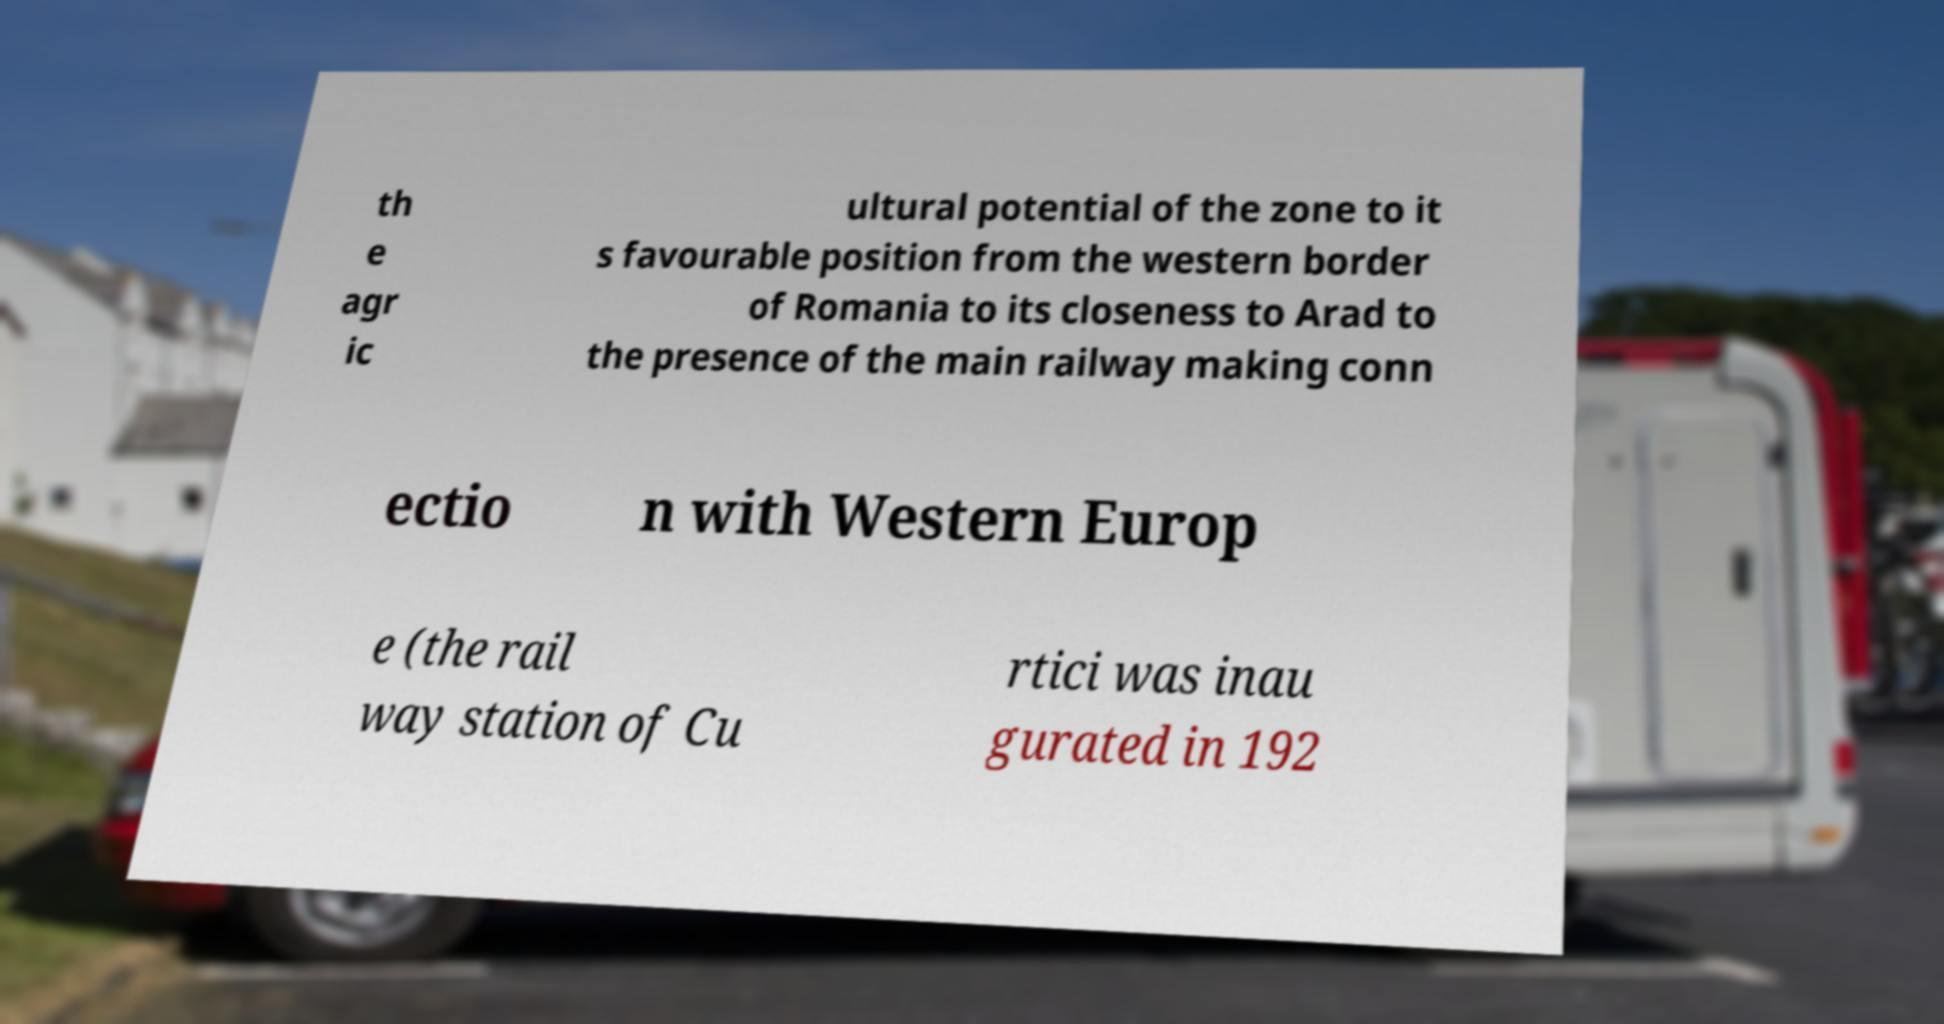I need the written content from this picture converted into text. Can you do that? th e agr ic ultural potential of the zone to it s favourable position from the western border of Romania to its closeness to Arad to the presence of the main railway making conn ectio n with Western Europ e (the rail way station of Cu rtici was inau gurated in 192 